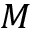<formula> <loc_0><loc_0><loc_500><loc_500>M</formula> 